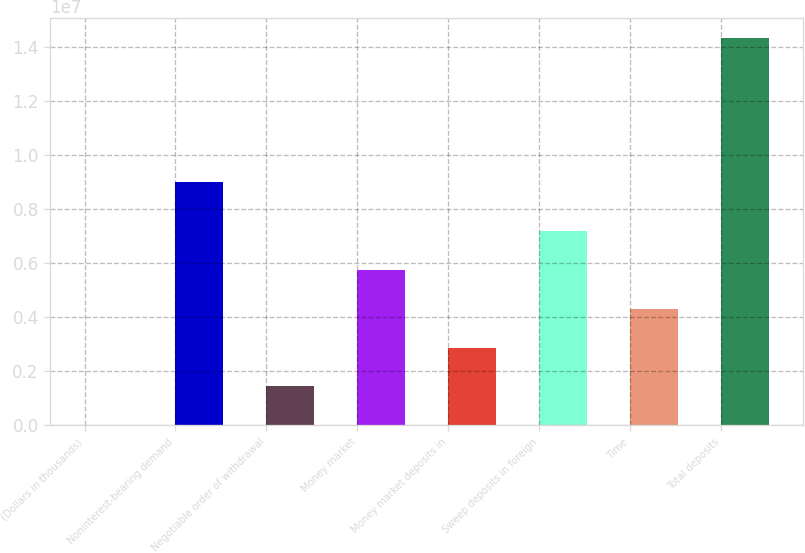Convert chart to OTSL. <chart><loc_0><loc_0><loc_500><loc_500><bar_chart><fcel>(Dollars in thousands)<fcel>Noninterest-bearing demand<fcel>Negotiable order of withdrawal<fcel>Money market<fcel>Money market deposits in<fcel>Sweep deposits in foreign<fcel>Time<fcel>Total deposits<nl><fcel>2010<fcel>9.01154e+06<fcel>1.4355e+06<fcel>5.73598e+06<fcel>2.869e+06<fcel>7.16948e+06<fcel>4.30249e+06<fcel>1.43369e+07<nl></chart> 